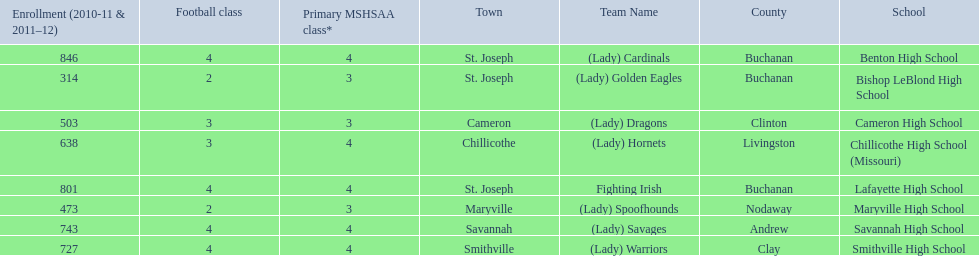What are the names of the schools? Benton High School, Bishop LeBlond High School, Cameron High School, Chillicothe High School (Missouri), Lafayette High School, Maryville High School, Savannah High School, Smithville High School. Of those, which had a total enrollment of less than 500? Bishop LeBlond High School, Maryville High School. And of those, which had the lowest enrollment? Bishop LeBlond High School. 